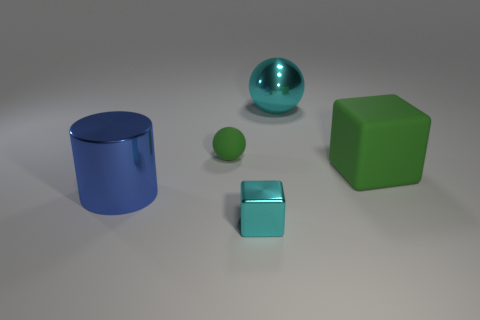Add 1 big green cubes. How many objects exist? 6 Subtract all cylinders. How many objects are left? 4 Subtract all big shiny cylinders. Subtract all green rubber cubes. How many objects are left? 3 Add 1 big metal cylinders. How many big metal cylinders are left? 2 Add 3 purple rubber cylinders. How many purple rubber cylinders exist? 3 Subtract 0 yellow cubes. How many objects are left? 5 